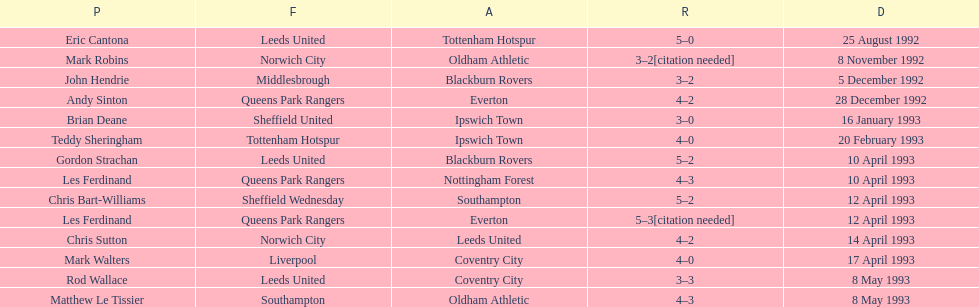Help me parse the entirety of this table. {'header': ['P', 'F', 'A', 'R', 'D'], 'rows': [['Eric Cantona', 'Leeds United', 'Tottenham Hotspur', '5–0', '25 August 1992'], ['Mark Robins', 'Norwich City', 'Oldham Athletic', '3–2[citation needed]', '8 November 1992'], ['John Hendrie', 'Middlesbrough', 'Blackburn Rovers', '3–2', '5 December 1992'], ['Andy Sinton', 'Queens Park Rangers', 'Everton', '4–2', '28 December 1992'], ['Brian Deane', 'Sheffield United', 'Ipswich Town', '3–0', '16 January 1993'], ['Teddy Sheringham', 'Tottenham Hotspur', 'Ipswich Town', '4–0', '20 February 1993'], ['Gordon Strachan', 'Leeds United', 'Blackburn Rovers', '5–2', '10 April 1993'], ['Les Ferdinand', 'Queens Park Rangers', 'Nottingham Forest', '4–3', '10 April 1993'], ['Chris Bart-Williams', 'Sheffield Wednesday', 'Southampton', '5–2', '12 April 1993'], ['Les Ferdinand', 'Queens Park Rangers', 'Everton', '5–3[citation needed]', '12 April 1993'], ['Chris Sutton', 'Norwich City', 'Leeds United', '4–2', '14 April 1993'], ['Mark Walters', 'Liverpool', 'Coventry City', '4–0', '17 April 1993'], ['Rod Wallace', 'Leeds United', 'Coventry City', '3–3', '8 May 1993'], ['Matthew Le Tissier', 'Southampton', 'Oldham Athletic', '4–3', '8 May 1993']]} Which team did liverpool play against? Coventry City. 